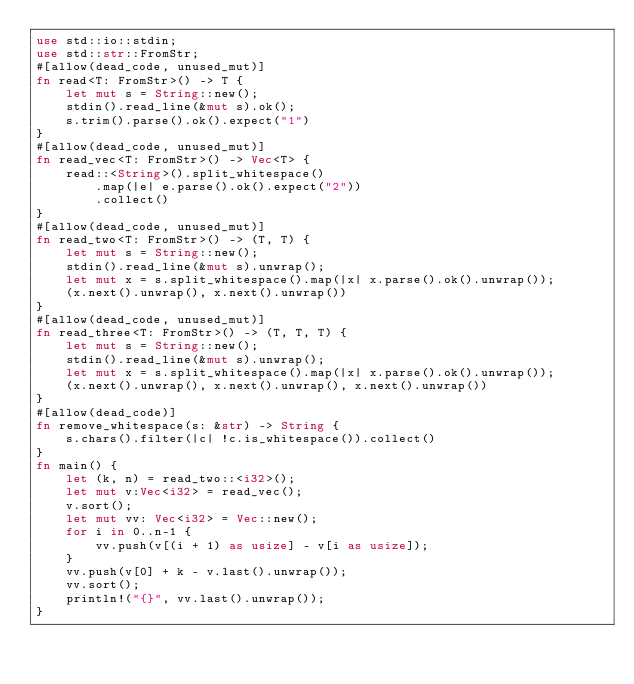Convert code to text. <code><loc_0><loc_0><loc_500><loc_500><_Rust_>use std::io::stdin;
use std::str::FromStr;
#[allow(dead_code, unused_mut)]
fn read<T: FromStr>() -> T {
    let mut s = String::new();
    stdin().read_line(&mut s).ok();
    s.trim().parse().ok().expect("1")
}
#[allow(dead_code, unused_mut)]
fn read_vec<T: FromStr>() -> Vec<T> {
    read::<String>().split_whitespace()
        .map(|e| e.parse().ok().expect("2"))
        .collect()
}
#[allow(dead_code, unused_mut)]
fn read_two<T: FromStr>() -> (T, T) {
    let mut s = String::new();
    stdin().read_line(&mut s).unwrap();
    let mut x = s.split_whitespace().map(|x| x.parse().ok().unwrap());
    (x.next().unwrap(), x.next().unwrap())
}
#[allow(dead_code, unused_mut)]
fn read_three<T: FromStr>() -> (T, T, T) {
    let mut s = String::new();
    stdin().read_line(&mut s).unwrap();
    let mut x = s.split_whitespace().map(|x| x.parse().ok().unwrap());
    (x.next().unwrap(), x.next().unwrap(), x.next().unwrap())
}
#[allow(dead_code)]
fn remove_whitespace(s: &str) -> String {
    s.chars().filter(|c| !c.is_whitespace()).collect()
}
fn main() {
    let (k, n) = read_two::<i32>();
    let mut v:Vec<i32> = read_vec();
    v.sort();
    let mut vv: Vec<i32> = Vec::new();
    for i in 0..n-1 {
        vv.push(v[(i + 1) as usize] - v[i as usize]);
    }
    vv.push(v[0] + k - v.last().unwrap());
    vv.sort();
    println!("{}", vv.last().unwrap());
}</code> 